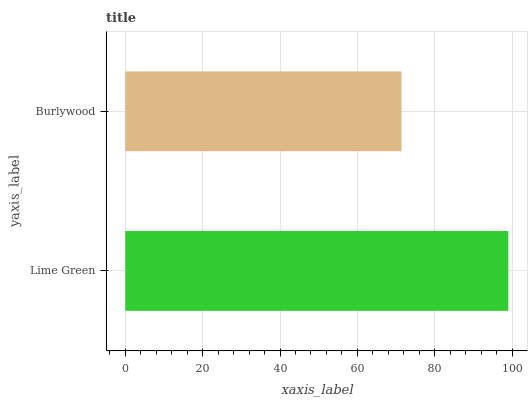Is Burlywood the minimum?
Answer yes or no. Yes. Is Lime Green the maximum?
Answer yes or no. Yes. Is Burlywood the maximum?
Answer yes or no. No. Is Lime Green greater than Burlywood?
Answer yes or no. Yes. Is Burlywood less than Lime Green?
Answer yes or no. Yes. Is Burlywood greater than Lime Green?
Answer yes or no. No. Is Lime Green less than Burlywood?
Answer yes or no. No. Is Lime Green the high median?
Answer yes or no. Yes. Is Burlywood the low median?
Answer yes or no. Yes. Is Burlywood the high median?
Answer yes or no. No. Is Lime Green the low median?
Answer yes or no. No. 